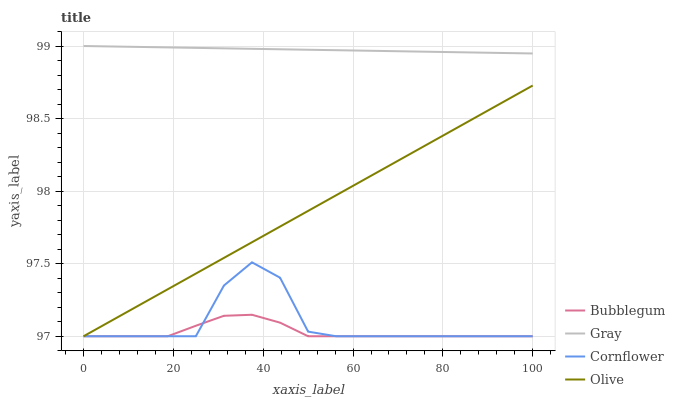Does Bubblegum have the minimum area under the curve?
Answer yes or no. Yes. Does Gray have the maximum area under the curve?
Answer yes or no. Yes. Does Gray have the minimum area under the curve?
Answer yes or no. No. Does Bubblegum have the maximum area under the curve?
Answer yes or no. No. Is Gray the smoothest?
Answer yes or no. Yes. Is Cornflower the roughest?
Answer yes or no. Yes. Is Bubblegum the smoothest?
Answer yes or no. No. Is Bubblegum the roughest?
Answer yes or no. No. Does Gray have the lowest value?
Answer yes or no. No. Does Gray have the highest value?
Answer yes or no. Yes. Does Bubblegum have the highest value?
Answer yes or no. No. Is Olive less than Gray?
Answer yes or no. Yes. Is Gray greater than Olive?
Answer yes or no. Yes. Does Olive intersect Cornflower?
Answer yes or no. Yes. Is Olive less than Cornflower?
Answer yes or no. No. Is Olive greater than Cornflower?
Answer yes or no. No. Does Olive intersect Gray?
Answer yes or no. No. 